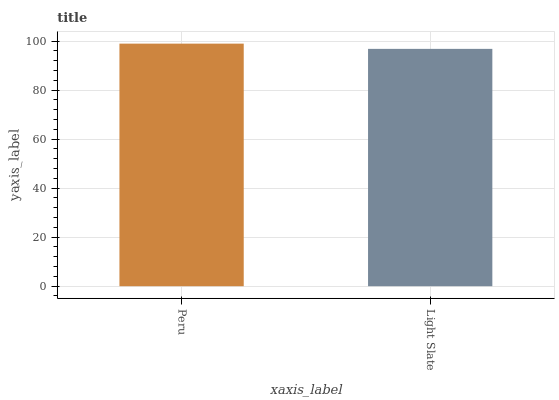Is Light Slate the maximum?
Answer yes or no. No. Is Peru greater than Light Slate?
Answer yes or no. Yes. Is Light Slate less than Peru?
Answer yes or no. Yes. Is Light Slate greater than Peru?
Answer yes or no. No. Is Peru less than Light Slate?
Answer yes or no. No. Is Peru the high median?
Answer yes or no. Yes. Is Light Slate the low median?
Answer yes or no. Yes. Is Light Slate the high median?
Answer yes or no. No. Is Peru the low median?
Answer yes or no. No. 